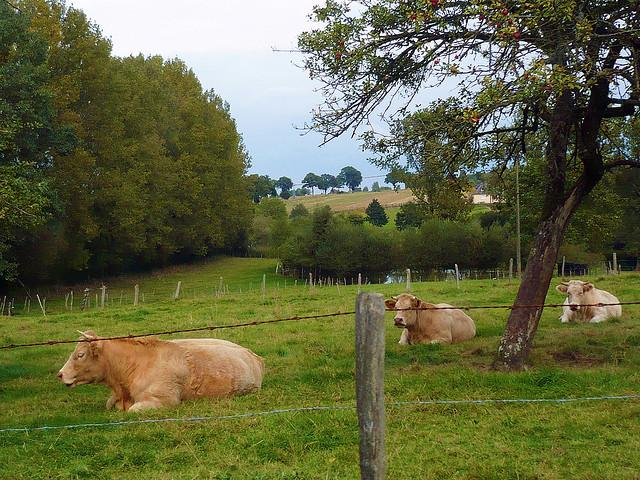What is strung on the fence to keep the cows in? Please explain your reasoning. wire. It has barbs on it to discourage them from running through it 